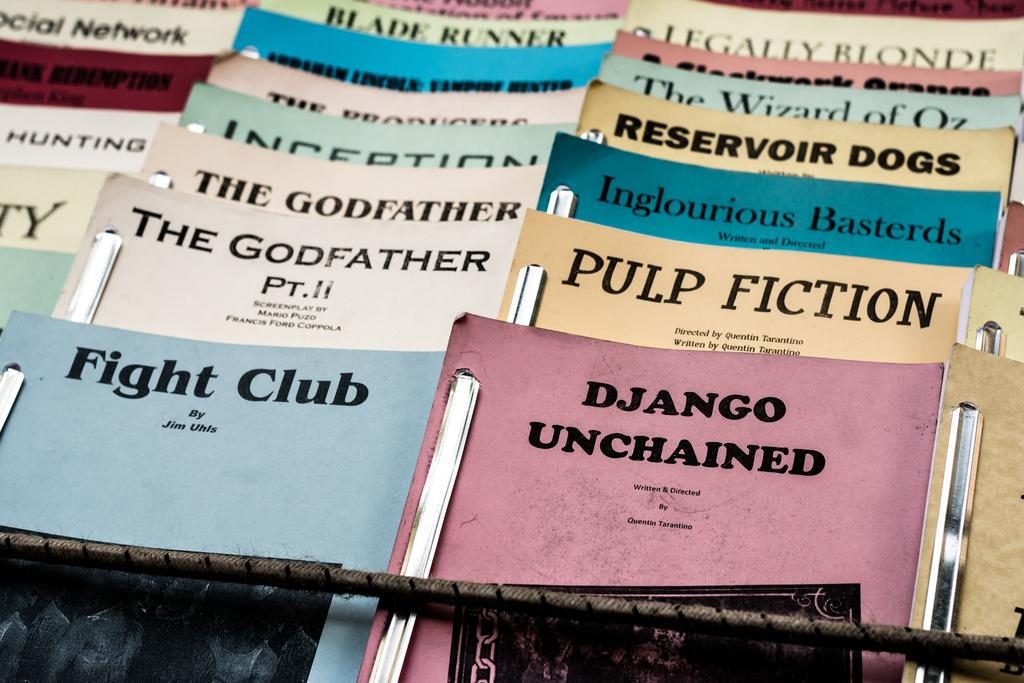<image>
Present a compact description of the photo's key features. A collection of books including Fight club, Pulp Fiction, The Godfather among others. 